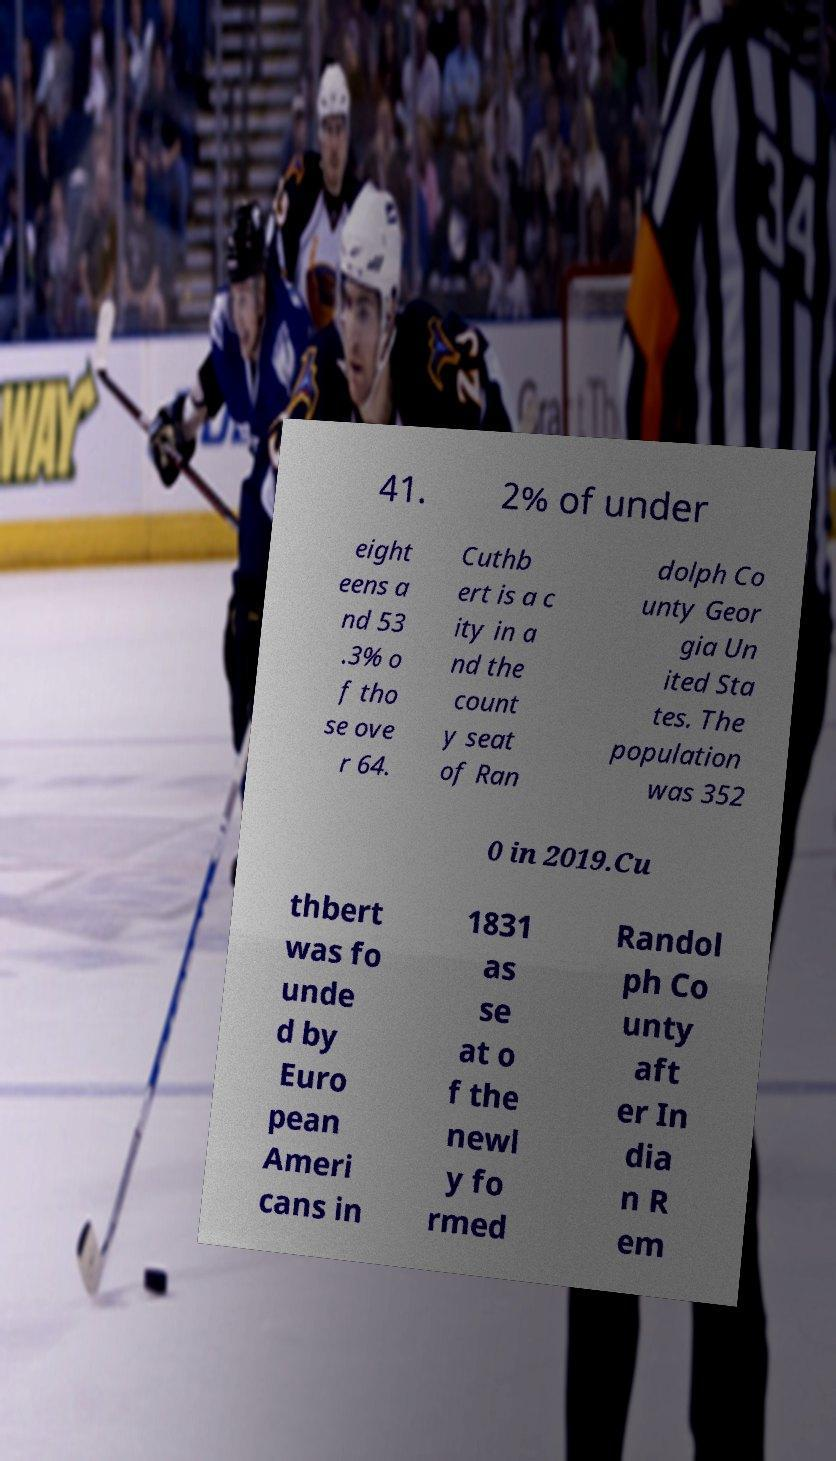Please read and relay the text visible in this image. What does it say? 41. 2% of under eight eens a nd 53 .3% o f tho se ove r 64. Cuthb ert is a c ity in a nd the count y seat of Ran dolph Co unty Geor gia Un ited Sta tes. The population was 352 0 in 2019.Cu thbert was fo unde d by Euro pean Ameri cans in 1831 as se at o f the newl y fo rmed Randol ph Co unty aft er In dia n R em 